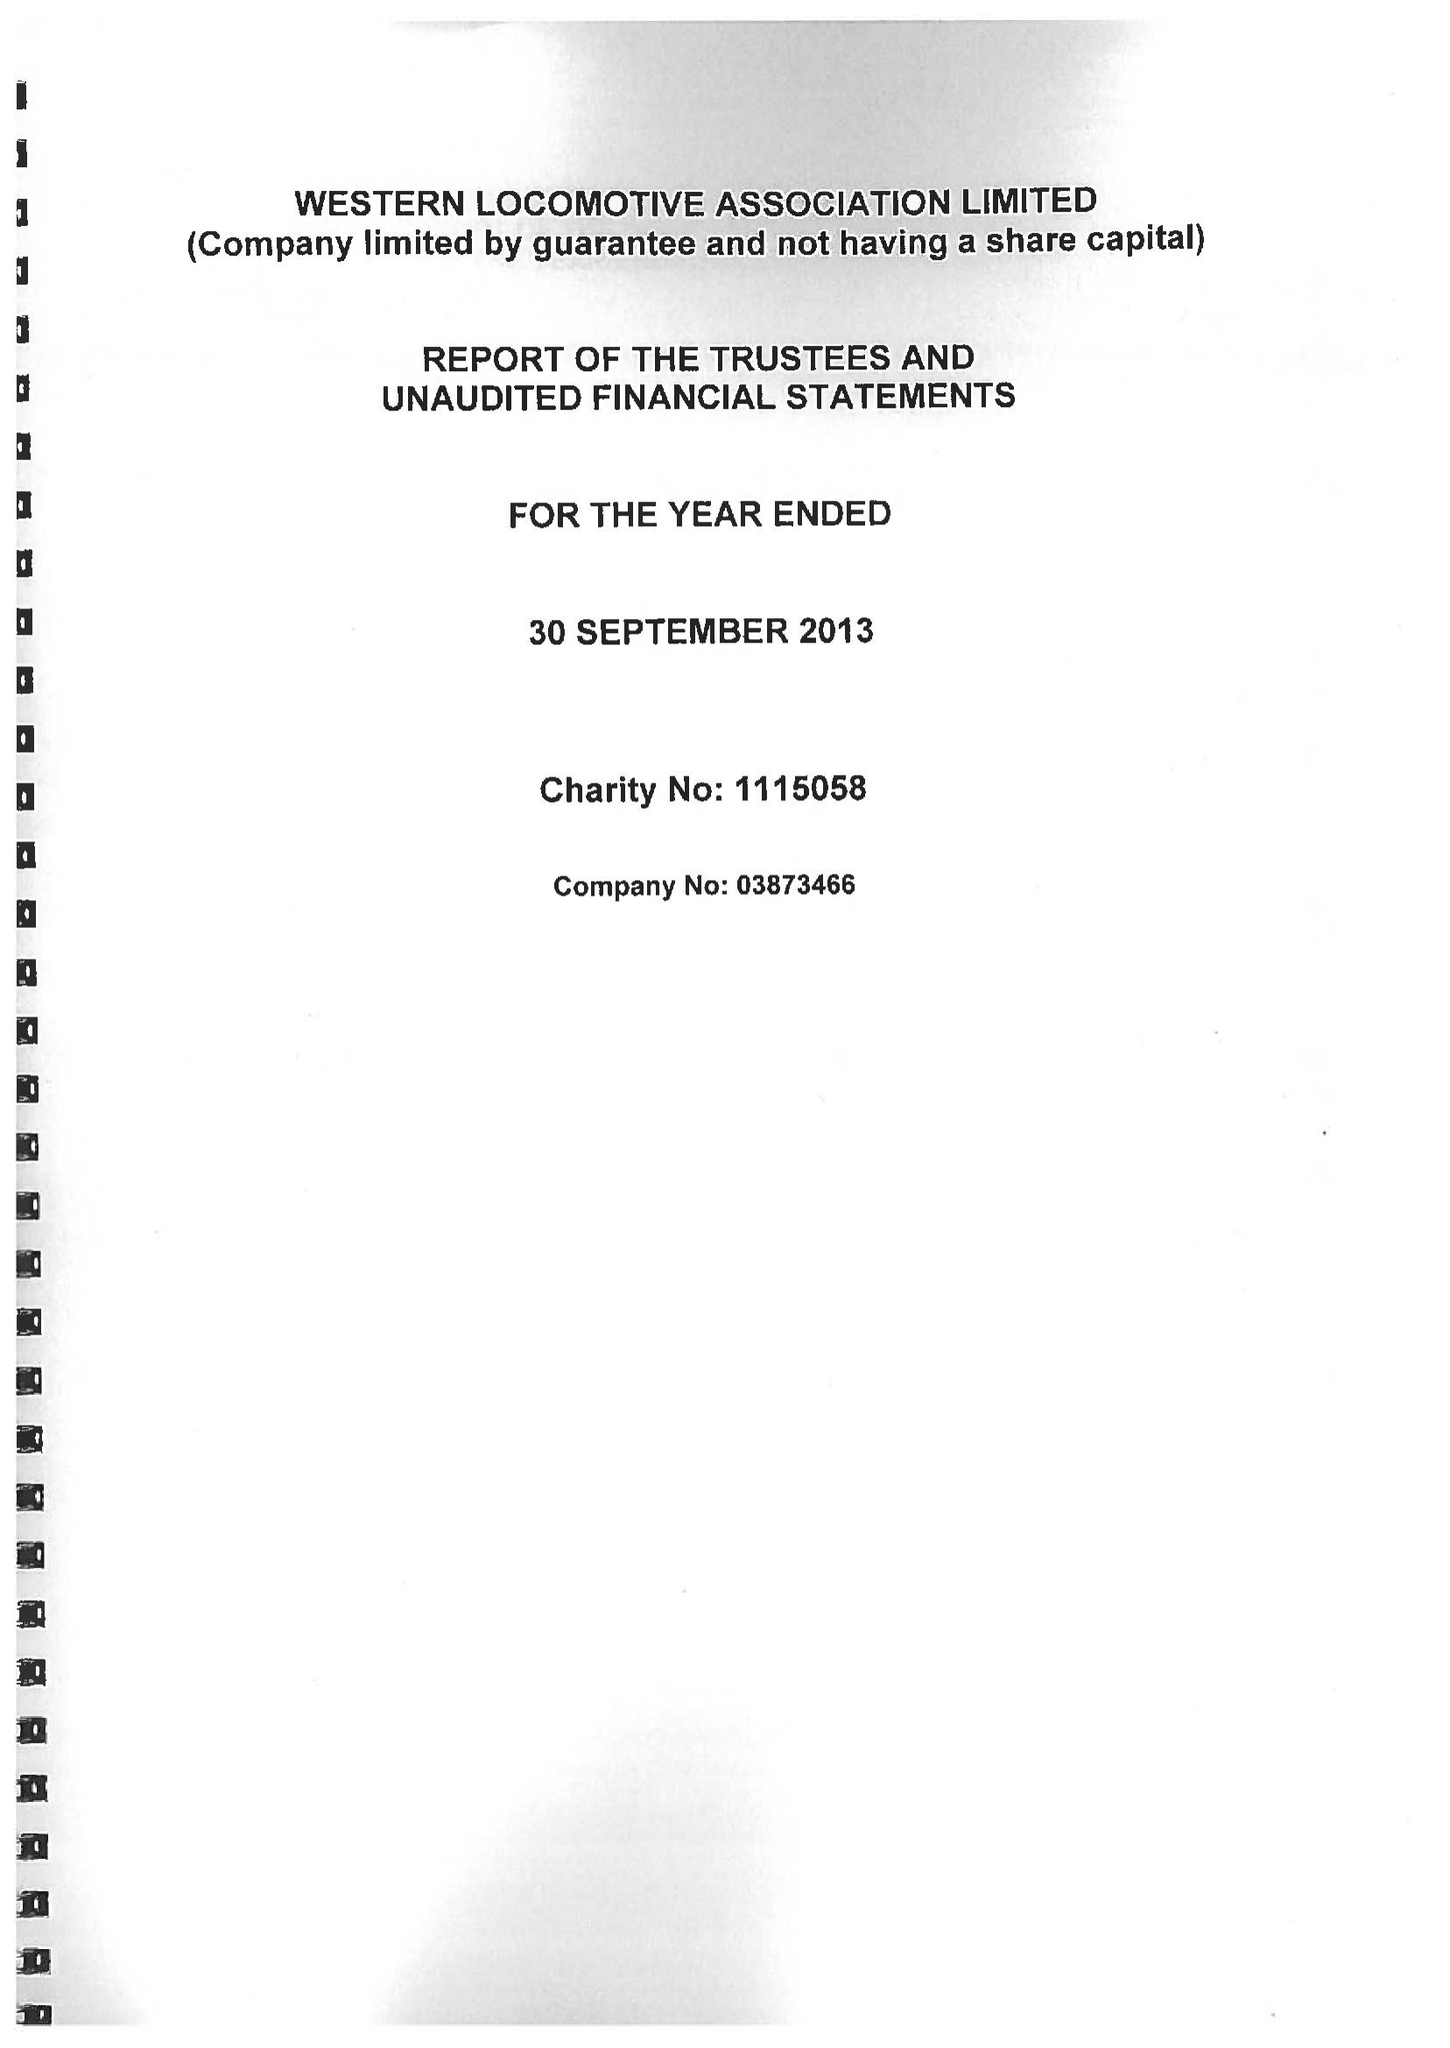What is the value for the spending_annually_in_british_pounds?
Answer the question using a single word or phrase. 28121.00 